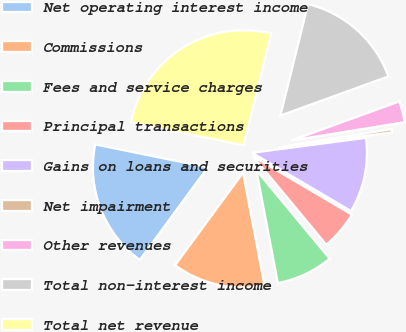<chart> <loc_0><loc_0><loc_500><loc_500><pie_chart><fcel>Net operating interest income<fcel>Commissions<fcel>Fees and service charges<fcel>Principal transactions<fcel>Gains on loans and securities<fcel>Net impairment<fcel>Other revenues<fcel>Total non-interest income<fcel>Total net revenue<nl><fcel>18.11%<fcel>13.07%<fcel>8.03%<fcel>5.51%<fcel>10.55%<fcel>0.47%<fcel>2.99%<fcel>15.59%<fcel>25.68%<nl></chart> 